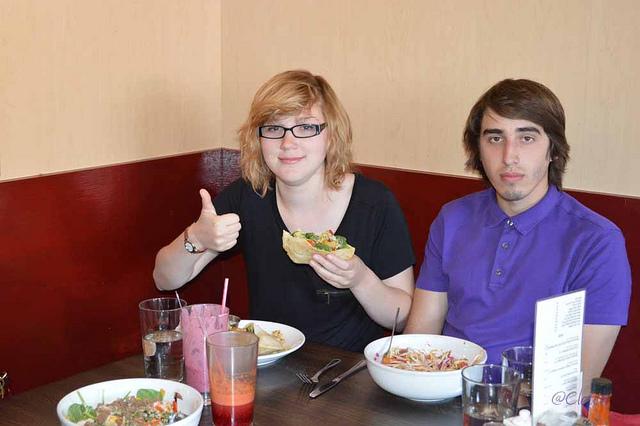How many people are male?
Keep it brief. 1. What sort of beverages are on the table?
Keep it brief. Smoothies. Are these people drinking alcoholic drinks?
Concise answer only. No. How many people are in the photo?
Keep it brief. 2. What is the man drinking?
Quick response, please. Water. Can children drink this?
Give a very brief answer. Yes. What color shirt is the guy wearing?
Keep it brief. Purple. Is everyone wearing the same color shirt in this photo?
Give a very brief answer. No. How many women are in this picture?
Concise answer only. 1. What is the expression of the person to the left?
Short answer required. Happy. Is anyone wearing glasses?
Give a very brief answer. Yes. Is the beer glass full?
Give a very brief answer. No. Is there acne?
Quick response, please. No. What face is the girl making?
Give a very brief answer. Smile. What is she drinking?
Give a very brief answer. Water. How many people are they in the picture?
Answer briefly. 2. Are they having milkshakes?
Be succinct. Yes. 